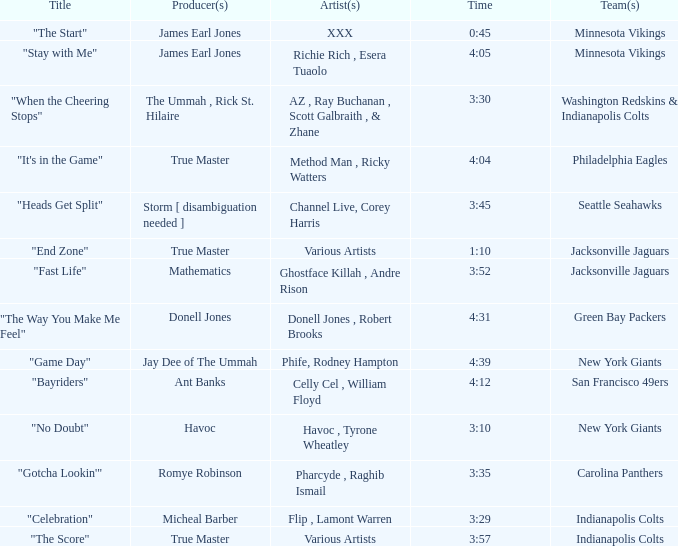Who is the artist of the New York Giants track "No Doubt"? Havoc , Tyrone Wheatley. 